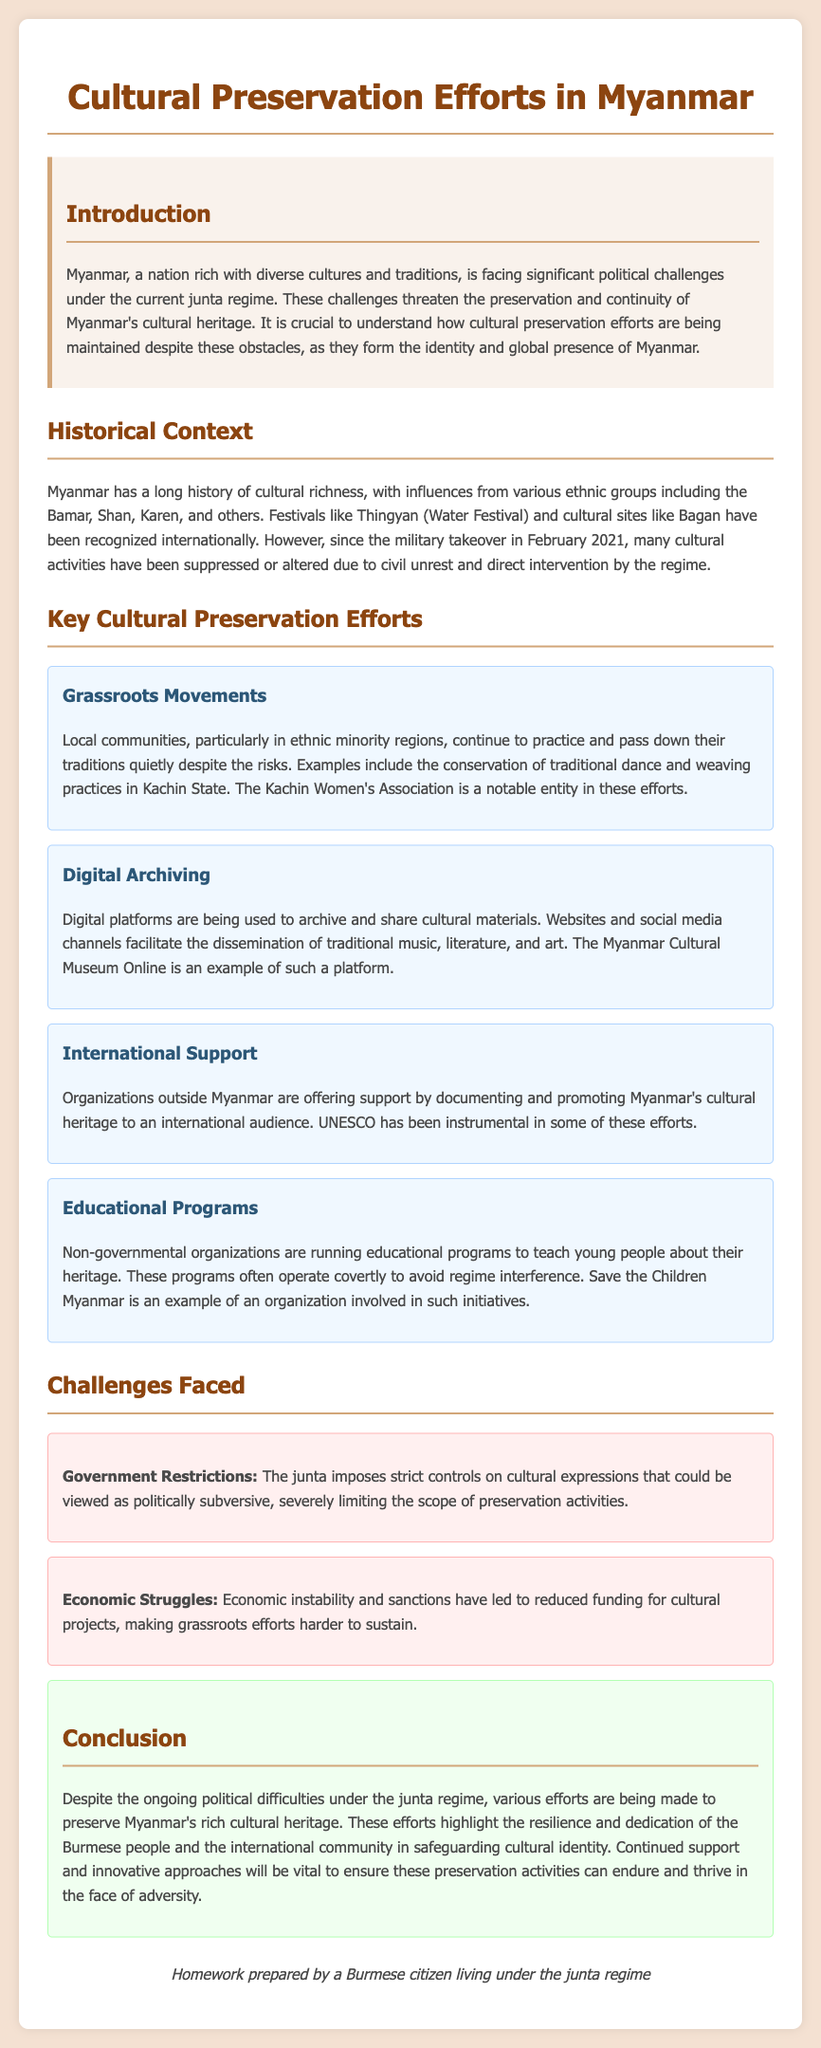What is the title of the document? The title is prominently displayed at the top of the document, which is "Cultural Preservation Efforts in Myanmar."
Answer: Cultural Preservation Efforts in Myanmar Who is the notable entity involved in grassroots movements? The document mentions the "Kachin Women's Association" as a notable entity in grassroots preservation efforts.
Answer: Kachin Women's Association What is one example of a cultural preservation effort mentioned? The document highlights various efforts, and one example is "Digital Archiving."
Answer: Digital Archiving What is a major challenge faced in cultural preservation? The document lists multiple challenges, one of which is "Government Restrictions."
Answer: Government Restrictions Which organization runs educational programs covertly? The document specifies "Save the Children Myanmar" as an organization involved in running educational programs about heritage.
Answer: Save the Children Myanmar What type of cultural materials are archived digitally? The document includes "traditional music, literature, and art" as materials being archived digitally.
Answer: traditional music, literature, and art What international organization is mentioned in relation to cultural heritage? The document states that "UNESCO" has been instrumental in supporting cultural heritage efforts.
Answer: UNESCO What has caused reduced funding for cultural projects? The document indicates that "Economic instability and sanctions" have led to reduced funding.
Answer: Economic instability and sanctions 